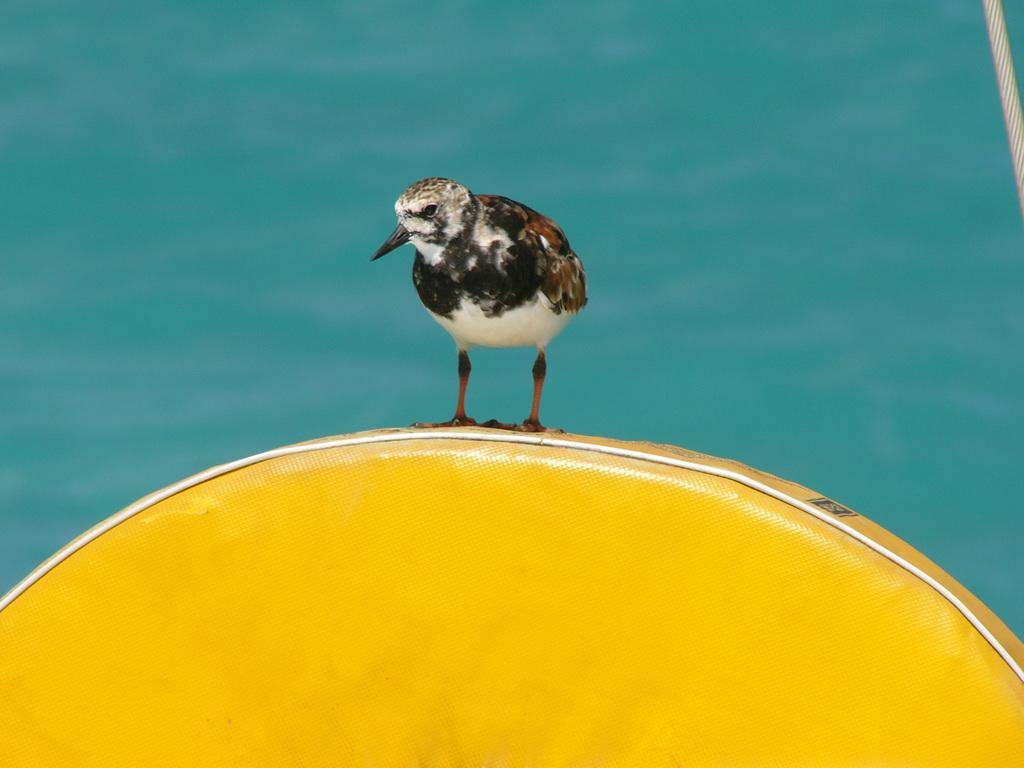What is the main object in the foreground of the image? There is a yellow chair in the foreground of the image. What is sitting on the yellow chair? A bird is present on the yellow chair. Can you describe anything in the right top corner of the image? There is a rope in the right top corner of the image. What can be seen in the background of the image? There is water visible in the background of the image. What type of faucet can be seen in the aftermath of the bird's landing on the yellow chair? There is no faucet present in the image, nor is there any indication of an aftermath from the bird's landing on the yellow chair. 